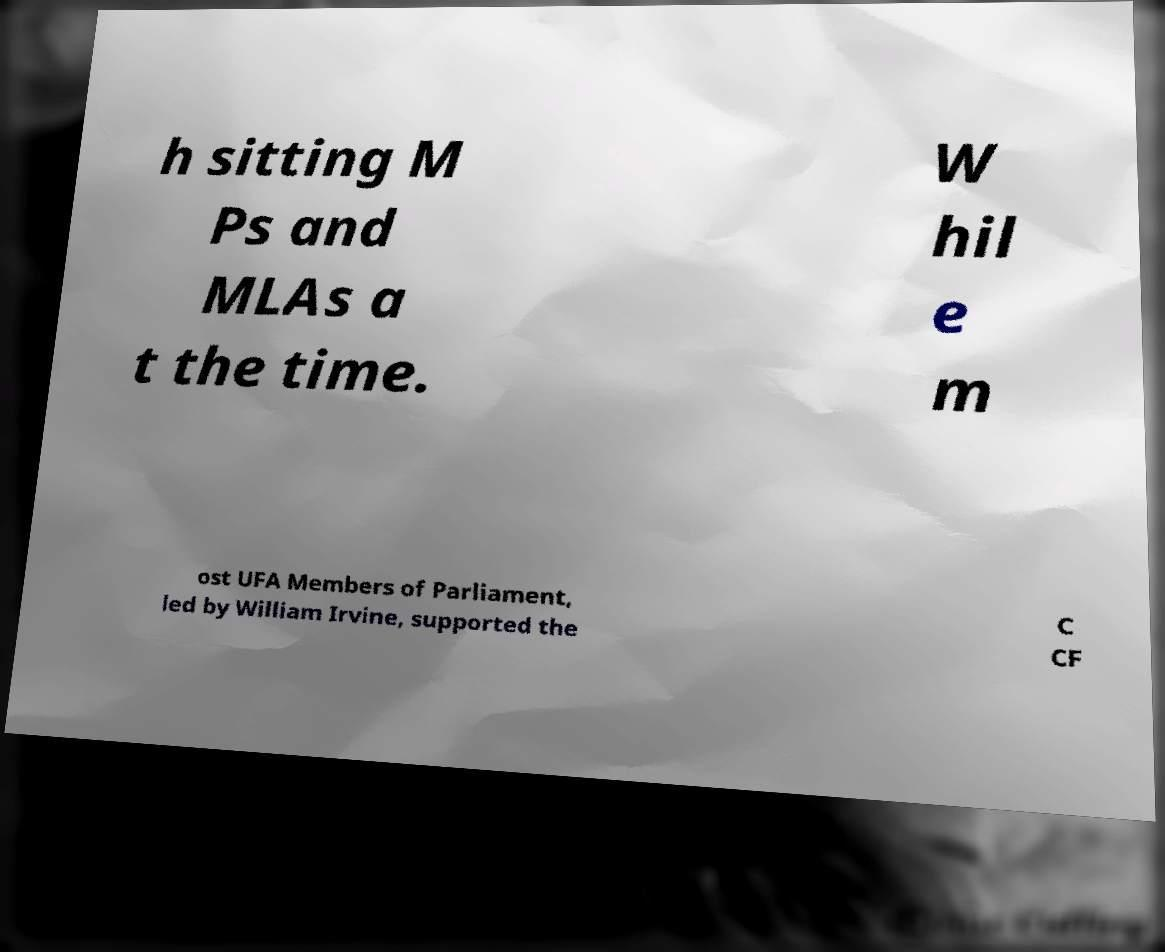Please identify and transcribe the text found in this image. h sitting M Ps and MLAs a t the time. W hil e m ost UFA Members of Parliament, led by William Irvine, supported the C CF 